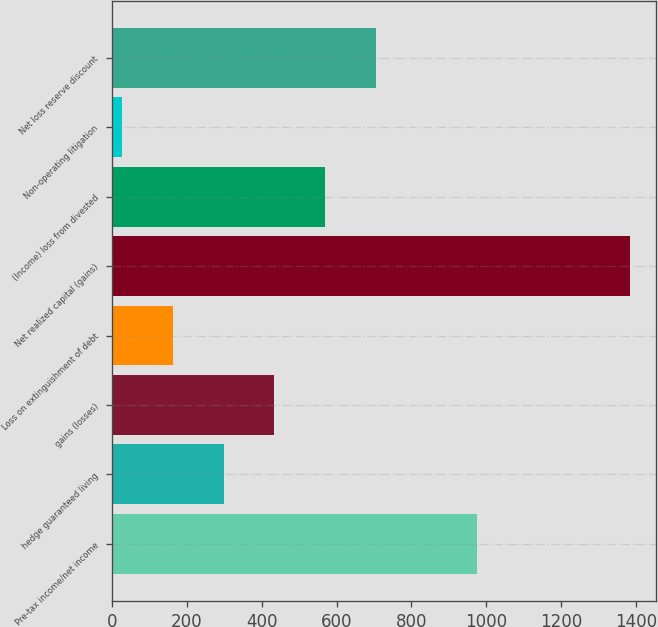Convert chart to OTSL. <chart><loc_0><loc_0><loc_500><loc_500><bar_chart><fcel>Pre-tax income/net income<fcel>hedge guaranteed living<fcel>gains (losses)<fcel>Loss on extinguishment of debt<fcel>Net realized capital (gains)<fcel>(Income) loss from divested<fcel>Non-operating litigation<fcel>Net loss reserve discount<nl><fcel>976.2<fcel>298.2<fcel>433.8<fcel>162.6<fcel>1383<fcel>569.4<fcel>27<fcel>705<nl></chart> 